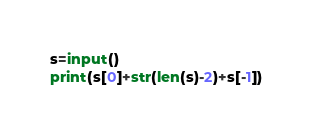Convert code to text. <code><loc_0><loc_0><loc_500><loc_500><_Python_>s=input()
print(s[0]+str(len(s)-2)+s[-1])</code> 